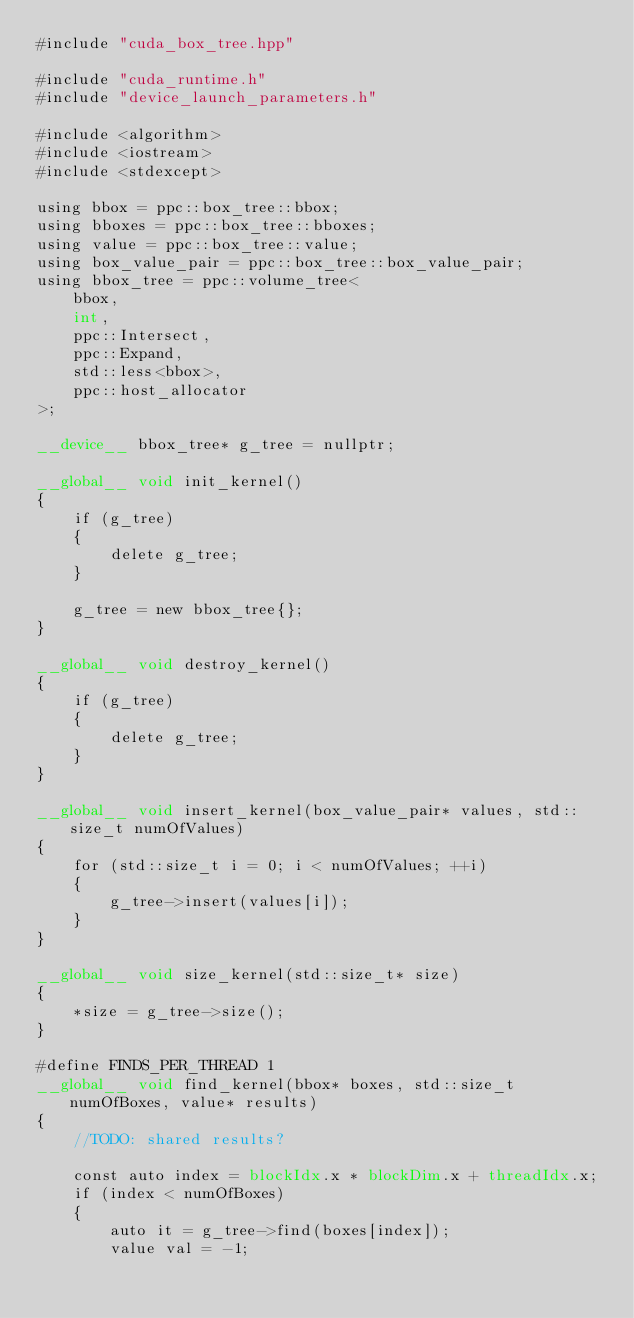Convert code to text. <code><loc_0><loc_0><loc_500><loc_500><_Cuda_>#include "cuda_box_tree.hpp"

#include "cuda_runtime.h"
#include "device_launch_parameters.h"

#include <algorithm>
#include <iostream>
#include <stdexcept>

using bbox = ppc::box_tree::bbox;
using bboxes = ppc::box_tree::bboxes;
using value = ppc::box_tree::value;
using box_value_pair = ppc::box_tree::box_value_pair;
using bbox_tree = ppc::volume_tree<
	bbox,
	int,
	ppc::Intersect,
	ppc::Expand,
	std::less<bbox>,
	ppc::host_allocator
>;

__device__ bbox_tree* g_tree = nullptr;

__global__ void init_kernel()
{
	if (g_tree)
	{
		delete g_tree;
	}
	
	g_tree = new bbox_tree{};
}

__global__ void destroy_kernel()
{
	if (g_tree)
	{
		delete g_tree;
	}
}

__global__ void insert_kernel(box_value_pair* values, std::size_t numOfValues)
{
	for (std::size_t i = 0; i < numOfValues; ++i)
	{
		g_tree->insert(values[i]);
	}
}

__global__ void size_kernel(std::size_t* size)
{
	*size = g_tree->size();
}

#define FINDS_PER_THREAD 1
__global__ void find_kernel(bbox* boxes, std::size_t numOfBoxes, value* results)
{
	//TODO: shared results?

	const auto index = blockIdx.x * blockDim.x + threadIdx.x;
	if (index < numOfBoxes)
	{
		auto it = g_tree->find(boxes[index]);
		value val = -1;</code> 